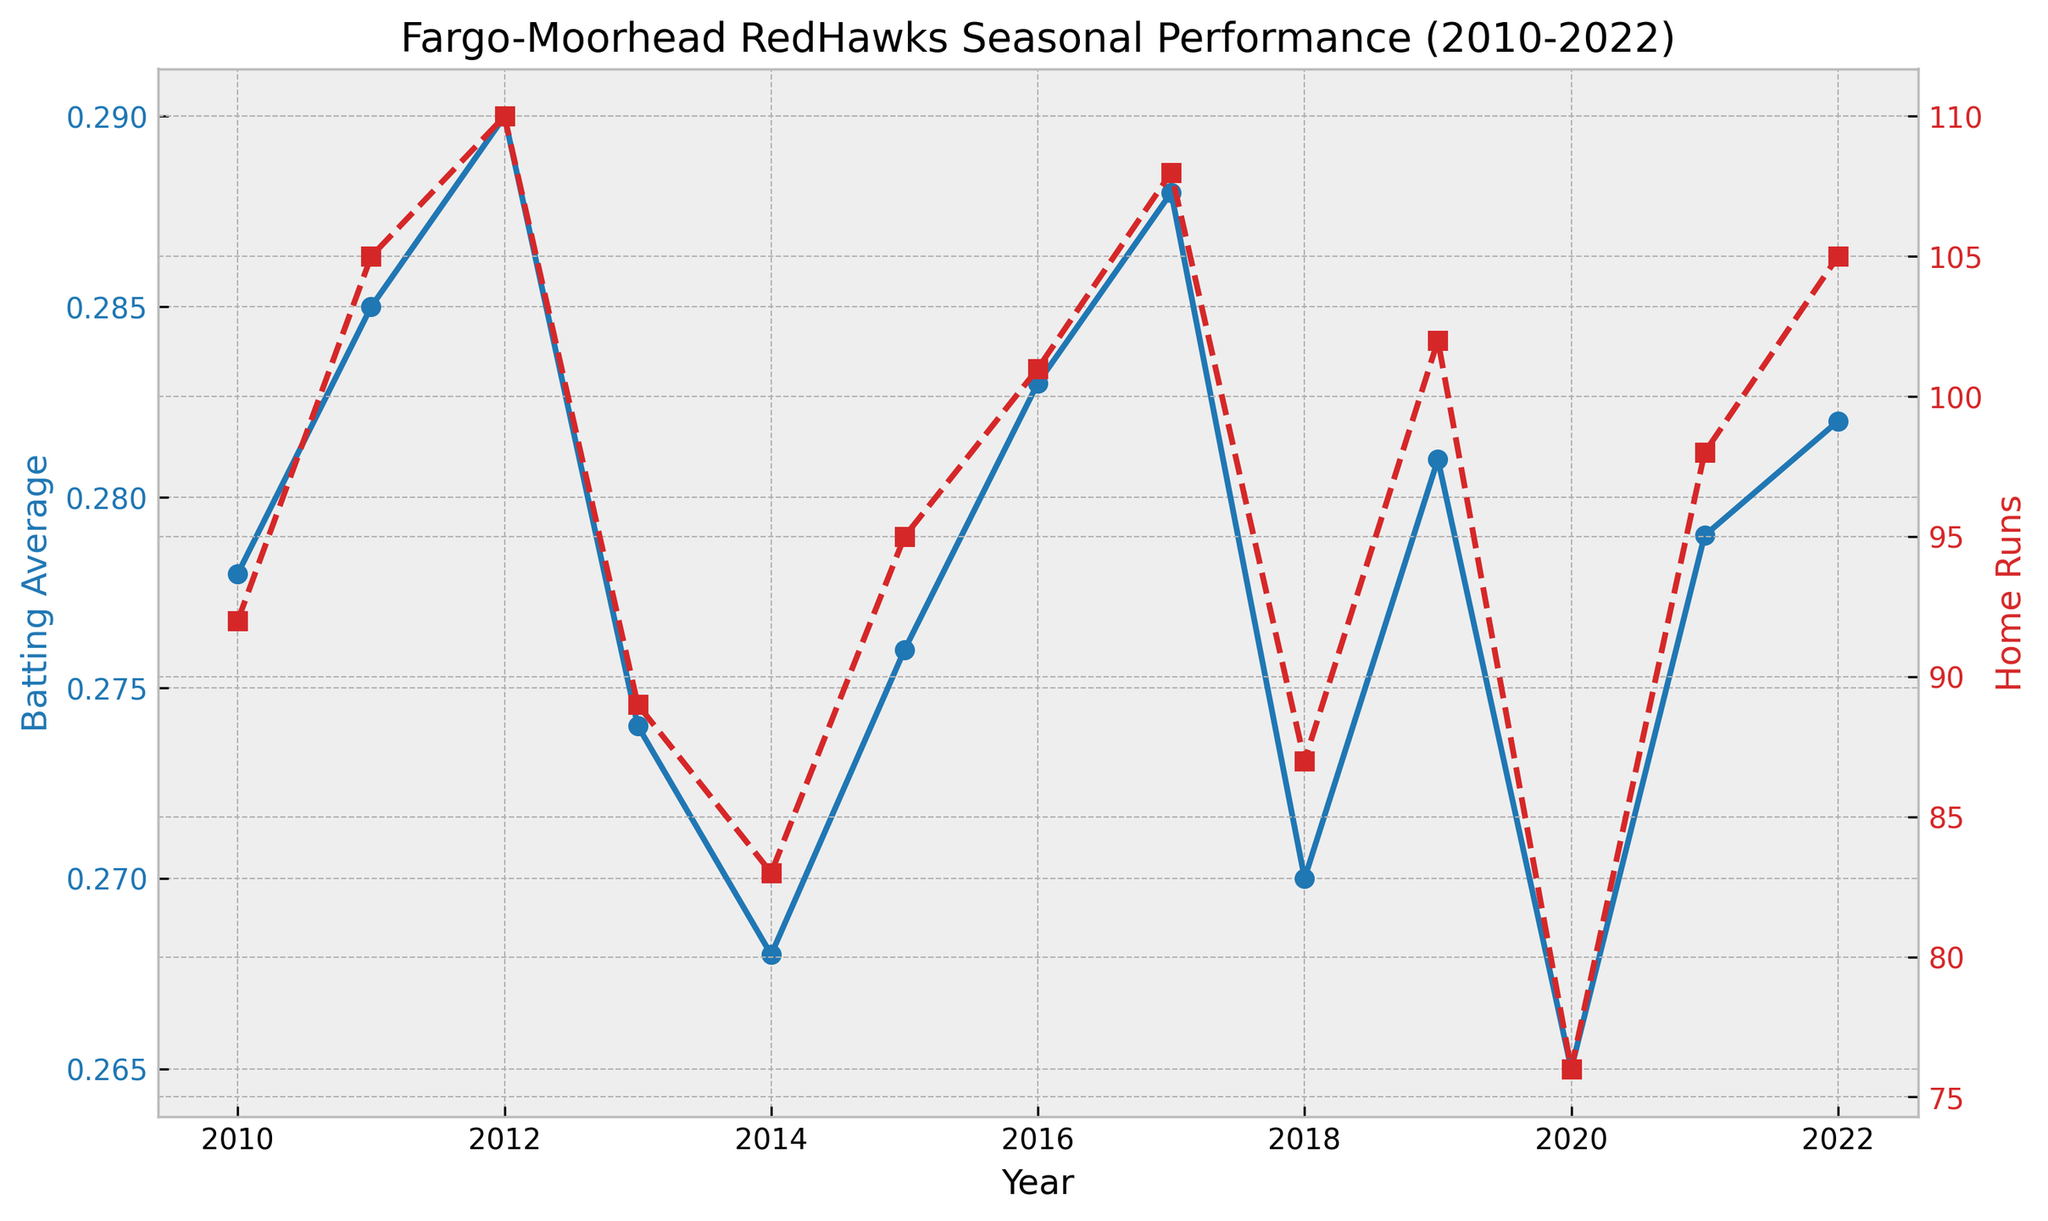What was the highest batting average in the given period? The highest point on the blue batting average line shows the highest batting average. This is at 2012 with a value of 0.290.
Answer: 0.290 How does the number of home runs in 2011 compare to 2010? To compare, we look at the red home run markers for 2011 and 2010. 2011 has 105 home runs while 2010 has 92. 2011 had more home runs.
Answer: More in 2011 Which year had the lowest number of home runs? The lowest point on the red home run line represents the lowest value. In 2020, the number of home runs dropped to 76.
Answer: 2020 In which year was the batting average the lowest, and what was the average that year? The lowest point of the batting average (blue line) indicates the lowest average. This was in 2020 with a batting average of 0.265.
Answer: 2020, 0.265 What is the difference in home runs between the years with the highest and lowest home runs? The highest number of home runs is 110 in 2012, and the lowest is 76 in 2020. The difference is 110 - 76 = 34.
Answer: 34 How did the batting average trend from 2010 to 2012? Look at the blue line from 2010 to 2012, which shows an upward trend from 0.278 to 0.290.
Answer: Upward Which year had equal values for home runs and the batting average? None of the years have the same numerical value for home runs and batting average. The batting average values are in decimal form and home run values are whole numbers.
Answer: None What is the average number of home runs from 2010 to 2022? Sum the home run values (92 + 105 + 110 + 89 + 83 + 95 + 101 + 108 + 87 + 102 + 76 + 98 + 105) and divide by 13. The total is 1251, and the average is 1251 / 13 = 96.23.
Answer: 96.23 What is the total increase in batting average from 2010 to 2021? The batting average in 2010 was 0.278 and in 2021 it was 0.279. The increase is 0.279 - 0.278 = 0.001.
Answer: 0.001 How does the home run trend from 2018 to 2020? The red line shows a downward trend from 87 in 2018 to 76 in 2020.
Answer: Downward 